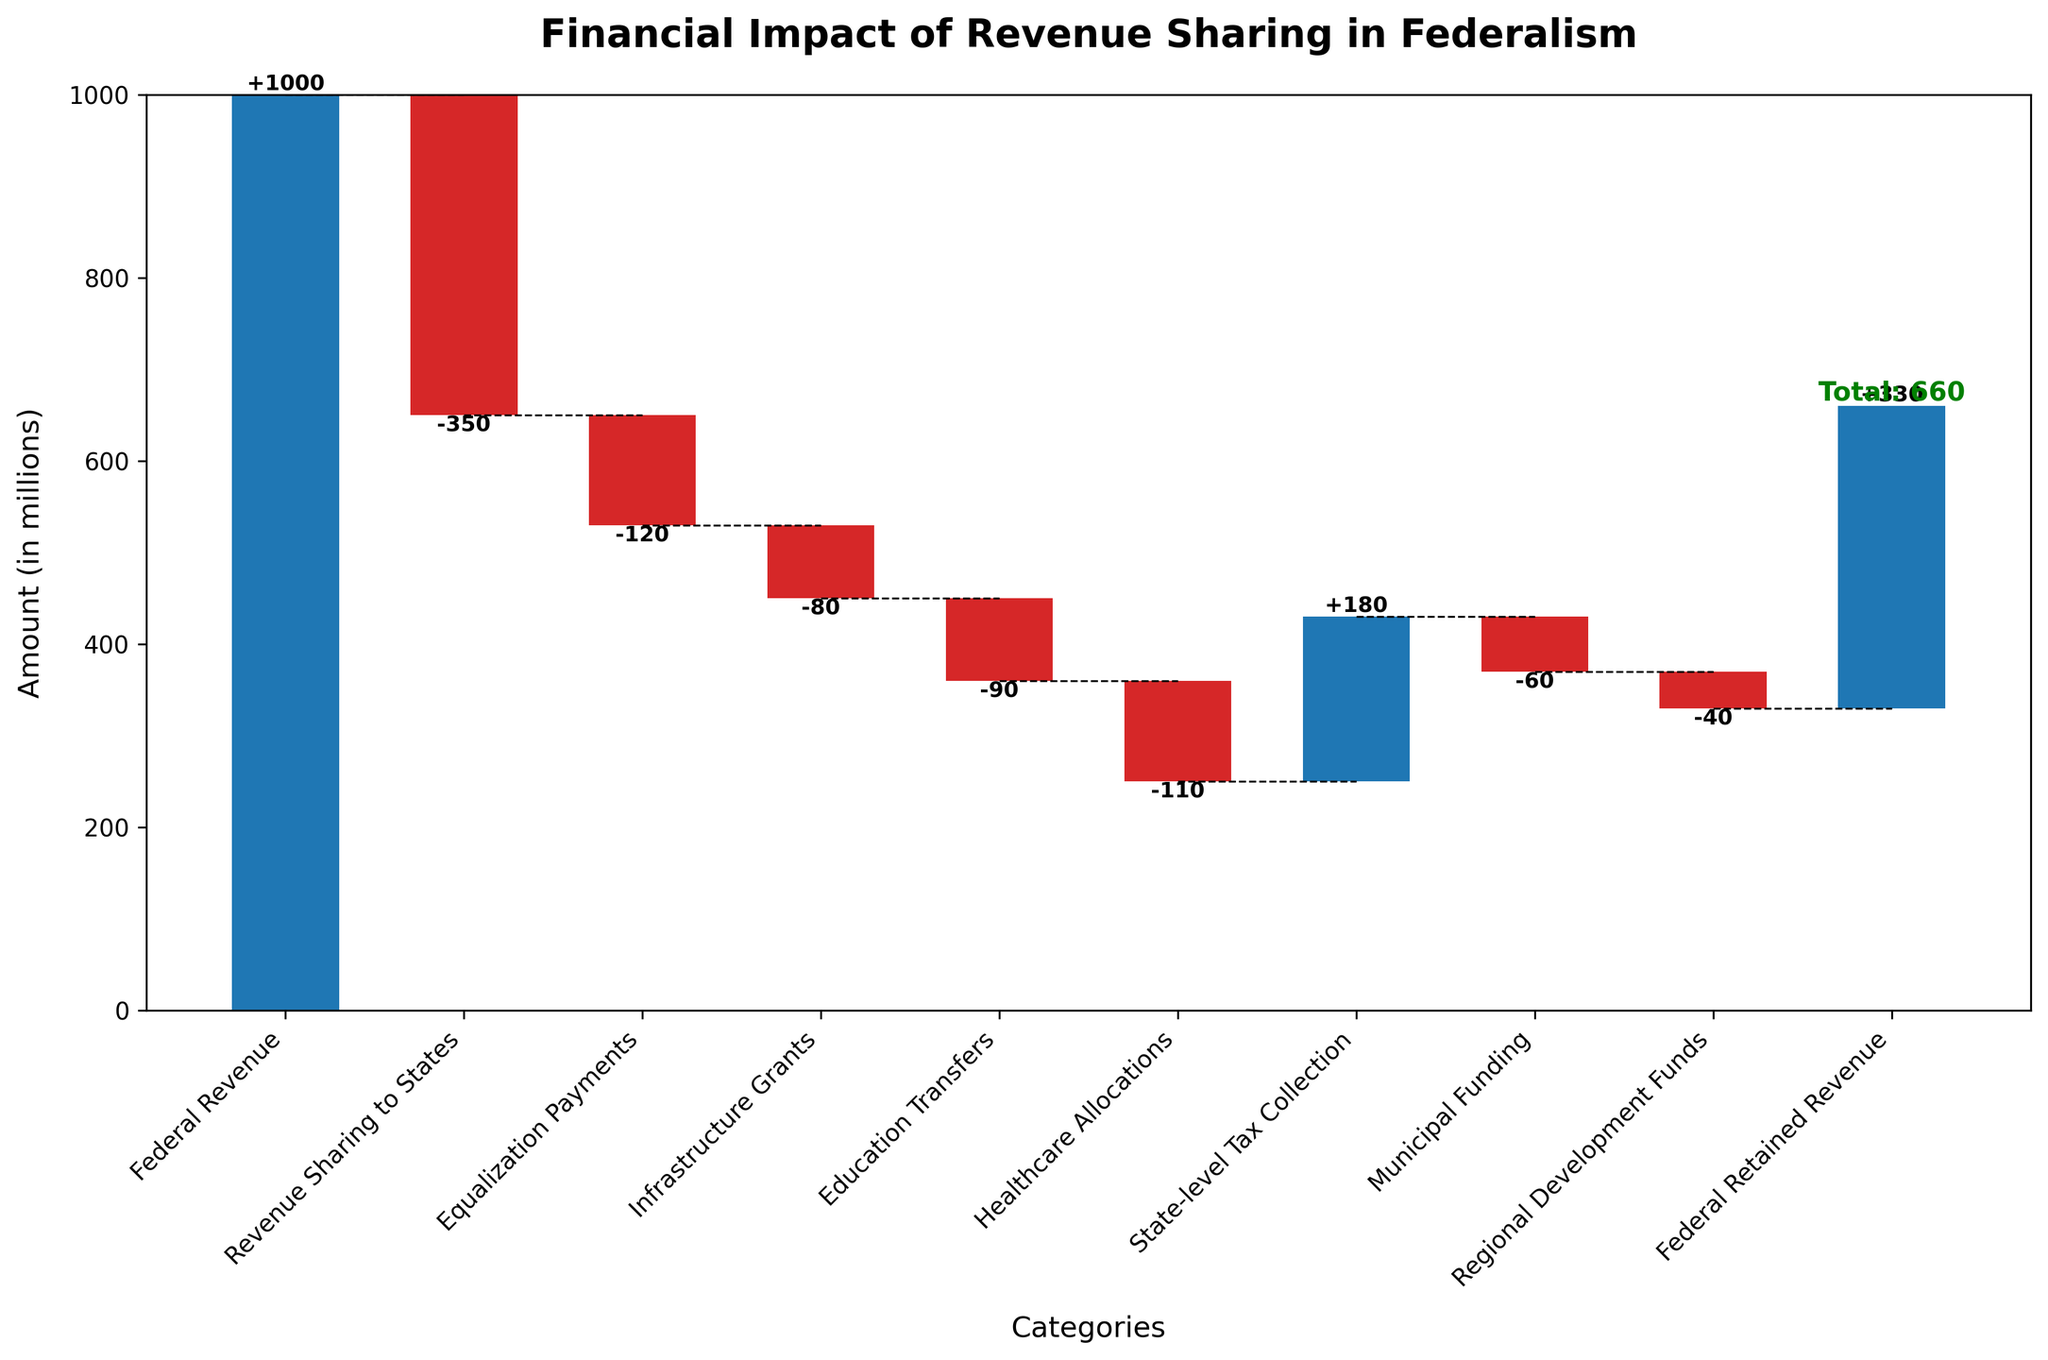What is the title of the Waterfall Chart? The title is typically displayed at the top of the chart and provides a summary of the entire chart's content. In this case, we can read the title directly from the chart.
Answer: Financial Impact of Revenue Sharing in Federalism What is the total Federal Revenue retained after all mechanisms? The final cumulative value represents the Federal Retained Revenue after all revenue sharing mechanisms. This value is found at the end of the chart, marked with a summary label.
Answer: 330 How much Federal Revenue is initially available before any allocations? The initial Federal Revenue is the starting value of the Waterfall Chart, represented by the first bar.
Answer: 1000 What is the cumulative financial impact after Education Transfers? This requires summing all values up to and including Education Transfers: 1000 (Federal Revenue) - 350 (Revenue Sharing to States) - 120 (Equalization Payments) - 80 (Infrastructure Grants) - 90 (Education Transfers) = 360.
Answer: 360 How do Infrastructure Grants and Healthcare Allocations compare in terms of financial impact? To compare, we look at the values for both categories. Infrastructure Grants have a value of -80, and Healthcare Allocations have a value of -110. By comparing these, we can see that Healthcare Allocations have a greater negative impact.
Answer: Healthcare Allocations have a greater negative impact What color represents the categories with negative impacts in this chart? Negative values in Waterfall Charts are typically represented with a specific color. In this chart, the categories with negative impacts are colored in red.
Answer: Red Which category adds the most positive value after Federal Revenue? After Federal Revenue, the category that adds the most positive value can be found by comparing the heights of the bars that result in an increase. State-level Tax Collection is the only positive value other than Federal Revenue, with a value of 180.
Answer: State-level Tax Collection What is the combined financial impact of Revenue Sharing to States and Municipal Funding? To find the combined impact, sum the two values directly: -350 (Revenue Sharing to States) + (-60) (Municipal Funding) = -410.
Answer: -410 How does the sum of all negative values affect the Federal Revenue? Sum all negative values and subtract that total from the initial Federal Revenue to see the effect: (-350) + (-120) + (-80) + (-90) + (-110) + (-60) + (-40) = -850. Then, 1000 - 850 = 150, indicating a reduction to 150 before State-level Tax Collection adds to it.
Answer: It reduces the Federal Revenue to 150 before State-level Tax Collection By how much does the cumulative revenue change from the start of the chart to the point just before the final category? To find this, sum all values except the final Federal Retained Revenue: 1000 - 350 - 120 - 80 - 90 - 110 + 180 - 60 - 40 = 330. This matches the value of Federal Retained Revenue, showing no additional change occurred at the last step other than summing up previous impacts.
Answer: 670 